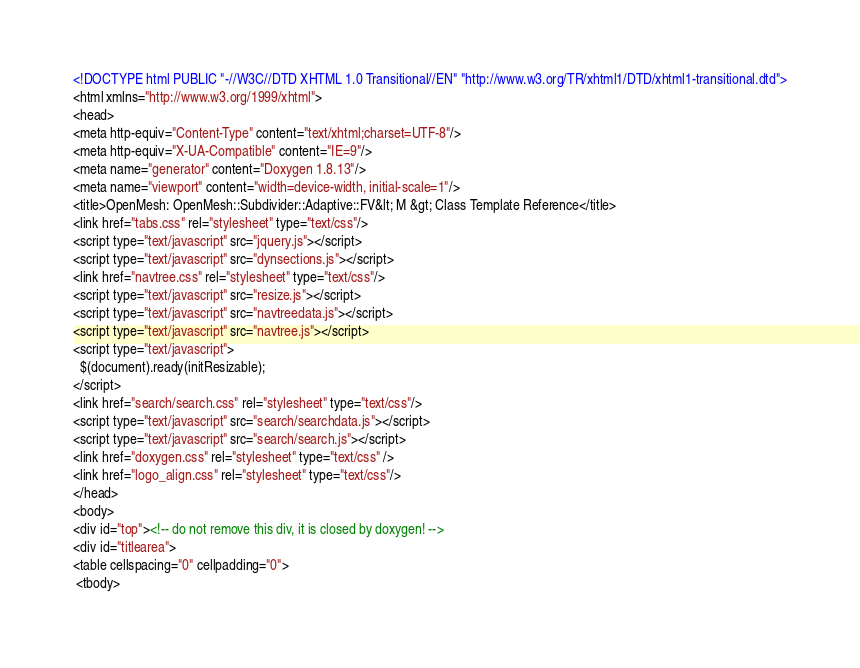<code> <loc_0><loc_0><loc_500><loc_500><_HTML_><!DOCTYPE html PUBLIC "-//W3C//DTD XHTML 1.0 Transitional//EN" "http://www.w3.org/TR/xhtml1/DTD/xhtml1-transitional.dtd">
<html xmlns="http://www.w3.org/1999/xhtml">
<head>
<meta http-equiv="Content-Type" content="text/xhtml;charset=UTF-8"/>
<meta http-equiv="X-UA-Compatible" content="IE=9"/>
<meta name="generator" content="Doxygen 1.8.13"/>
<meta name="viewport" content="width=device-width, initial-scale=1"/>
<title>OpenMesh: OpenMesh::Subdivider::Adaptive::FV&lt; M &gt; Class Template Reference</title>
<link href="tabs.css" rel="stylesheet" type="text/css"/>
<script type="text/javascript" src="jquery.js"></script>
<script type="text/javascript" src="dynsections.js"></script>
<link href="navtree.css" rel="stylesheet" type="text/css"/>
<script type="text/javascript" src="resize.js"></script>
<script type="text/javascript" src="navtreedata.js"></script>
<script type="text/javascript" src="navtree.js"></script>
<script type="text/javascript">
  $(document).ready(initResizable);
</script>
<link href="search/search.css" rel="stylesheet" type="text/css"/>
<script type="text/javascript" src="search/searchdata.js"></script>
<script type="text/javascript" src="search/search.js"></script>
<link href="doxygen.css" rel="stylesheet" type="text/css" />
<link href="logo_align.css" rel="stylesheet" type="text/css"/>
</head>
<body>
<div id="top"><!-- do not remove this div, it is closed by doxygen! -->
<div id="titlearea">
<table cellspacing="0" cellpadding="0">
 <tbody></code> 